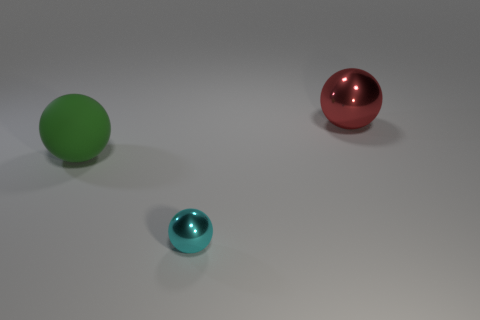Is there anything else that is made of the same material as the green object?
Make the answer very short. No. What is the shape of the big thing that is the same material as the small cyan thing?
Provide a succinct answer. Sphere. What size is the thing on the left side of the shiny thing that is in front of the red shiny object?
Make the answer very short. Large. How many objects are either large matte things that are on the left side of the red metallic sphere or objects that are right of the green object?
Provide a short and direct response. 3. Are there fewer tiny metal things than large cyan matte blocks?
Give a very brief answer. No. How many objects are either red metal spheres or brown objects?
Your response must be concise. 1. Is the tiny cyan shiny thing the same shape as the big green object?
Offer a terse response. Yes. Do the cyan metallic thing that is in front of the rubber sphere and the shiny ball behind the big green matte thing have the same size?
Ensure brevity in your answer.  No. There is a sphere that is to the left of the red object and on the right side of the green rubber ball; what is its material?
Keep it short and to the point. Metal. Are there any other things of the same color as the big rubber sphere?
Your response must be concise. No. 